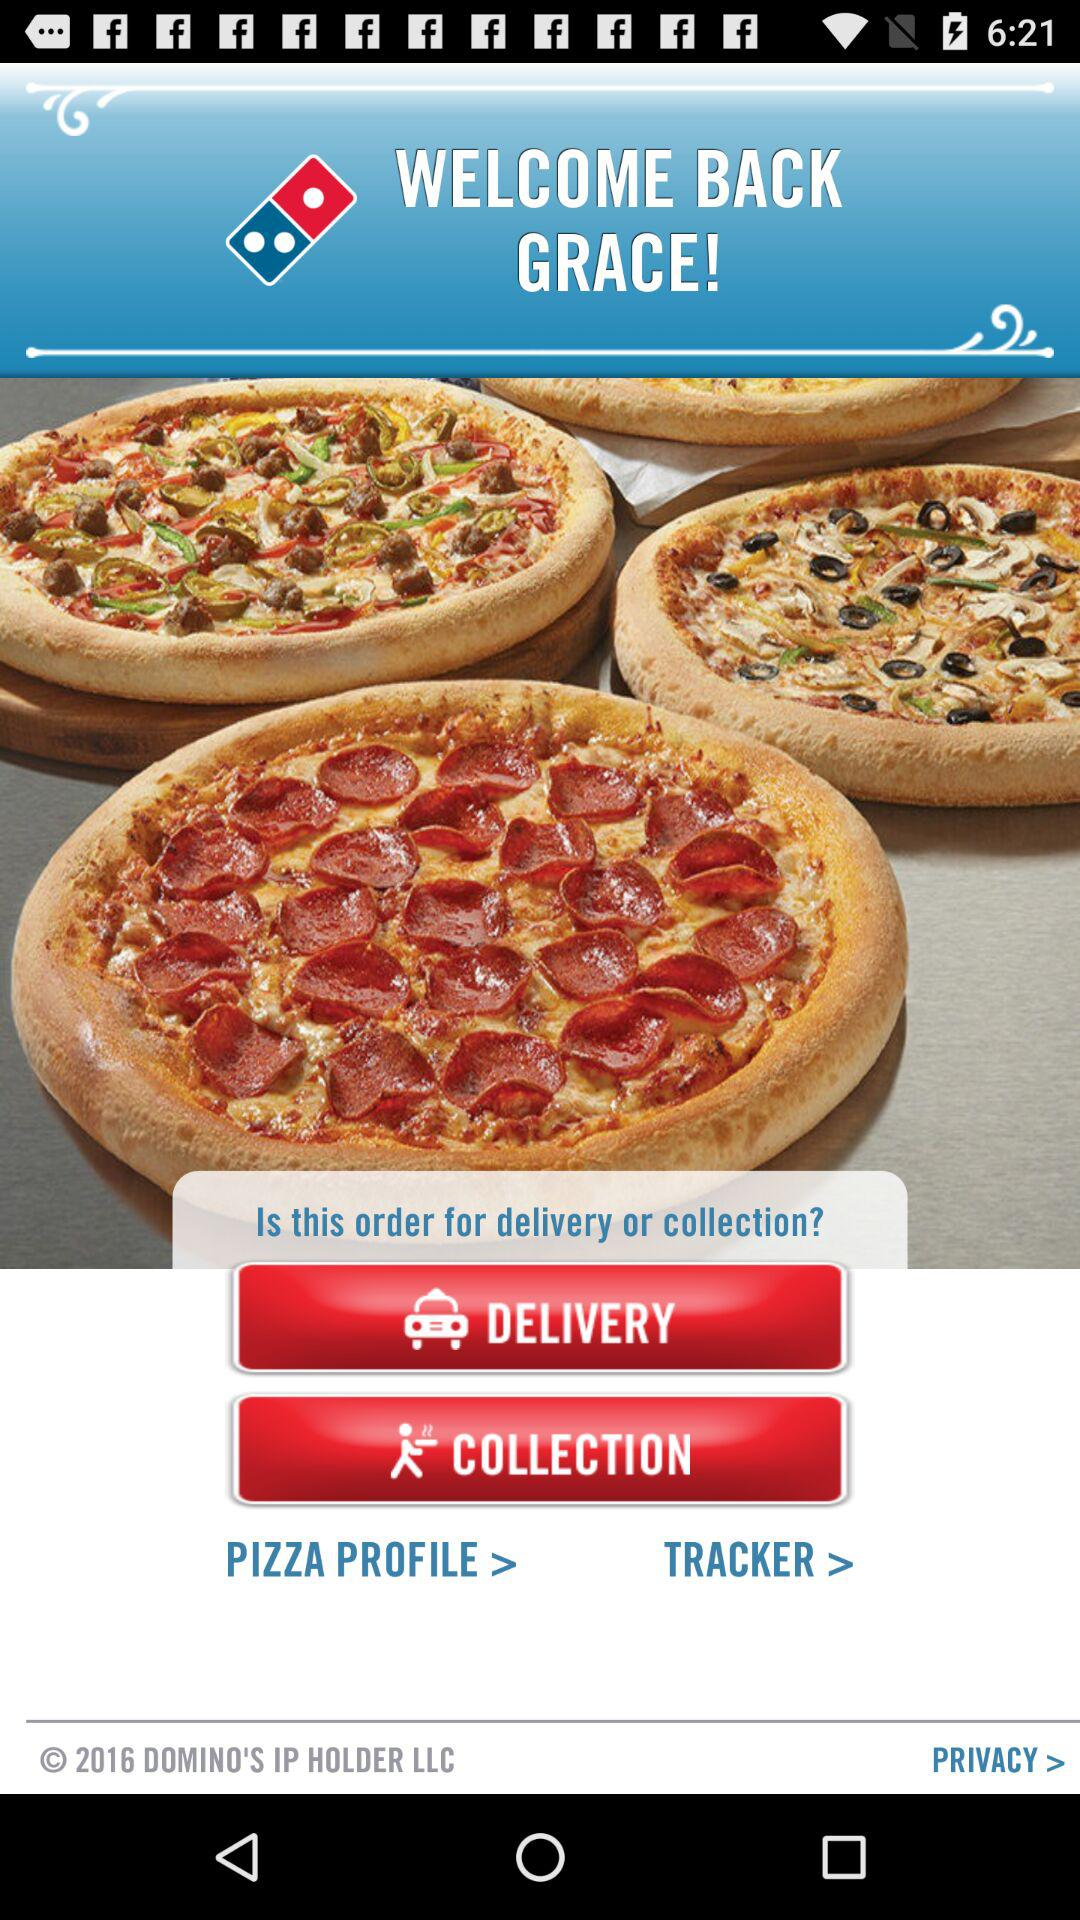What type of pizza is being ordered?
When the provided information is insufficient, respond with <no answer>. <no answer> 